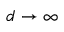Convert formula to latex. <formula><loc_0><loc_0><loc_500><loc_500>d \to \infty</formula> 